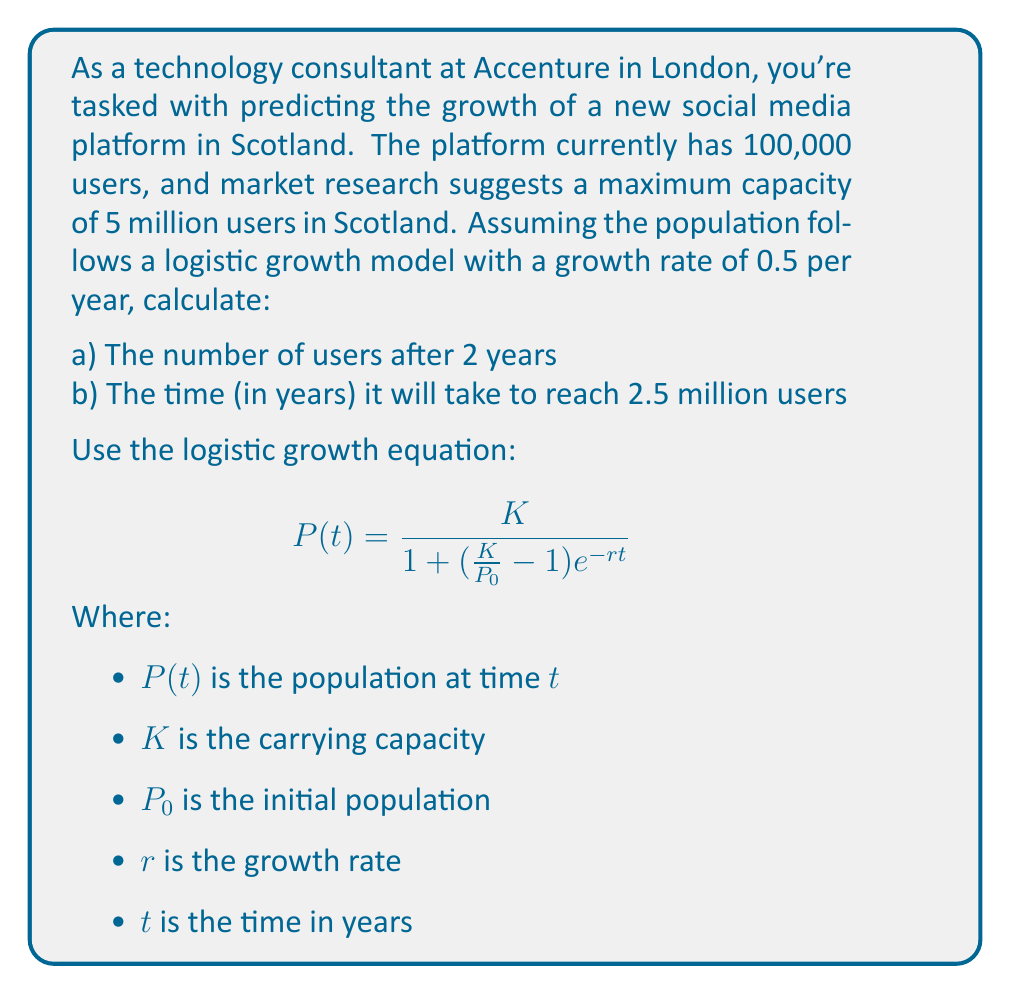Give your solution to this math problem. Let's approach this step-by-step:

Given:
$P_0 = 100,000$
$K = 5,000,000$
$r = 0.5$ per year

a) To find the number of users after 2 years:

Substitute the values into the logistic growth equation:

$$P(2) = \frac{5,000,000}{1 + (\frac{5,000,000}{100,000} - 1)e^{-0.5 \cdot 2}}$$

$$= \frac{5,000,000}{1 + 49e^{-1}}$$

$$= \frac{5,000,000}{1 + 49 \cdot 0.3679}$$

$$= \frac{5,000,000}{19.0271}$$

$$= 262,783$$ (rounded to nearest whole number)

b) To find the time to reach 2.5 million users:

Use the same equation, but solve for $t$:

$$2,500,000 = \frac{5,000,000}{1 + (\frac{5,000,000}{100,000} - 1)e^{-0.5t}}$$

Simplify:

$$0.5 = \frac{1}{1 + 49e^{-0.5t}}$$

$$1 = 2(1 + 49e^{-0.5t})$$

$$0 = 1 + 49e^{-0.5t} - \frac{1}{2}$$

$$\frac{1}{2} = 49e^{-0.5t}$$

$$\frac{1}{98} = e^{-0.5t}$$

$$\ln(\frac{1}{98}) = -0.5t$$

$$t = \frac{-2\ln(\frac{1}{98})}{0.5} = 8.77$$ years (rounded to 2 decimal places)
Answer: a) 262,783 users
b) 8.77 years 